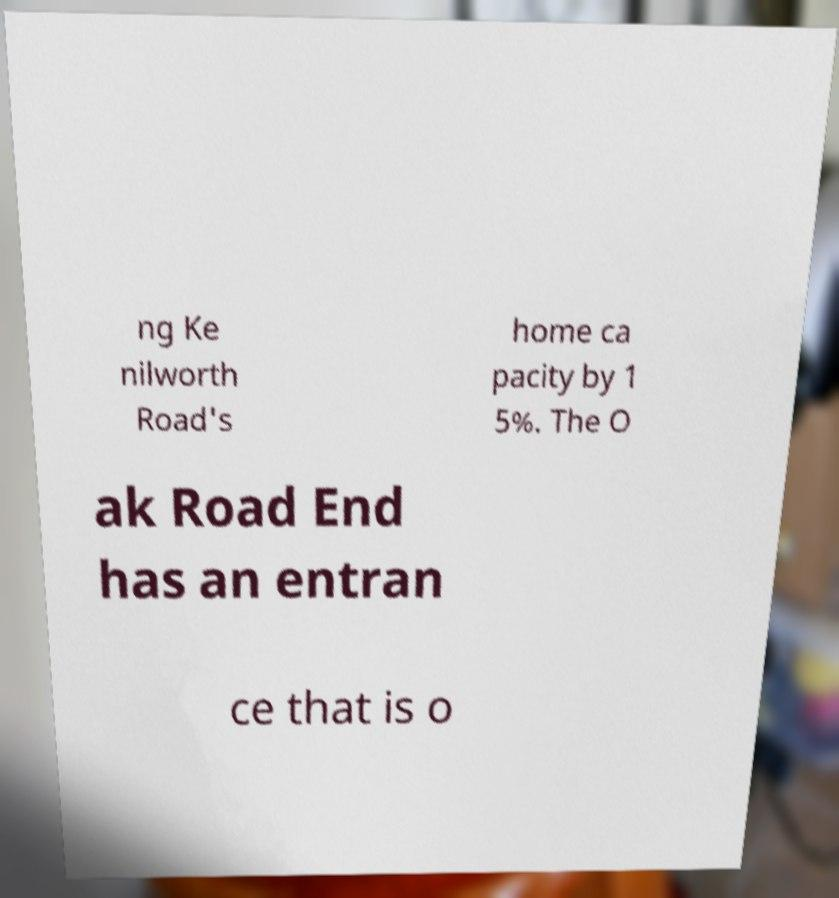There's text embedded in this image that I need extracted. Can you transcribe it verbatim? ng Ke nilworth Road's home ca pacity by 1 5%. The O ak Road End has an entran ce that is o 